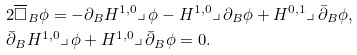<formula> <loc_0><loc_0><loc_500><loc_500>& 2 \overline { \square } _ { B } \phi = - \partial _ { B } H ^ { 1 , 0 } \lrcorner \, \phi - H ^ { 1 , 0 } \lrcorner \, \partial _ { B } \phi + H ^ { 0 , 1 } \lrcorner \, \bar { \partial } _ { B } \phi , \\ & \bar { \partial } _ { B } H ^ { 1 , 0 } \lrcorner \, \phi + H ^ { 1 , 0 } \lrcorner \, \bar { \partial } _ { B } \phi = 0 .</formula> 